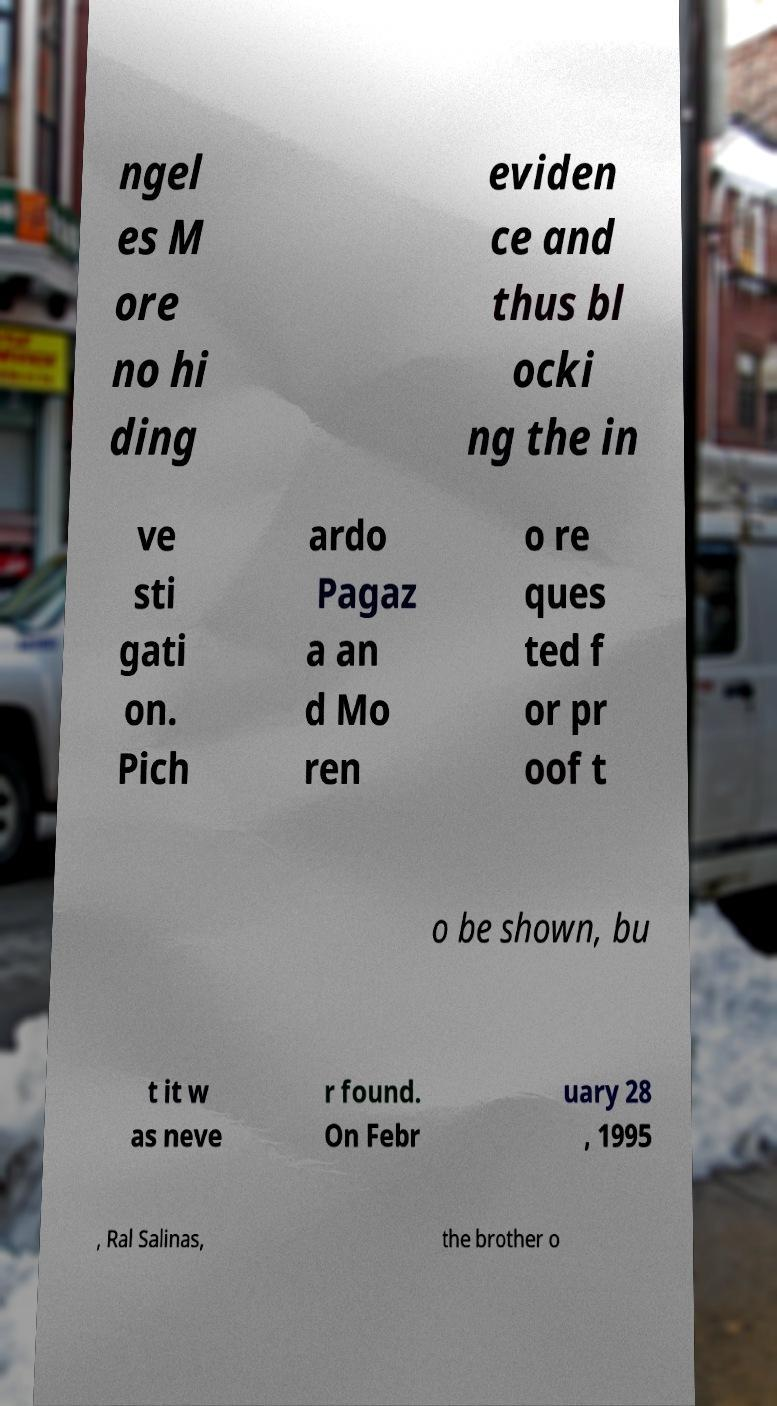What messages or text are displayed in this image? I need them in a readable, typed format. ngel es M ore no hi ding eviden ce and thus bl ocki ng the in ve sti gati on. Pich ardo Pagaz a an d Mo ren o re ques ted f or pr oof t o be shown, bu t it w as neve r found. On Febr uary 28 , 1995 , Ral Salinas, the brother o 